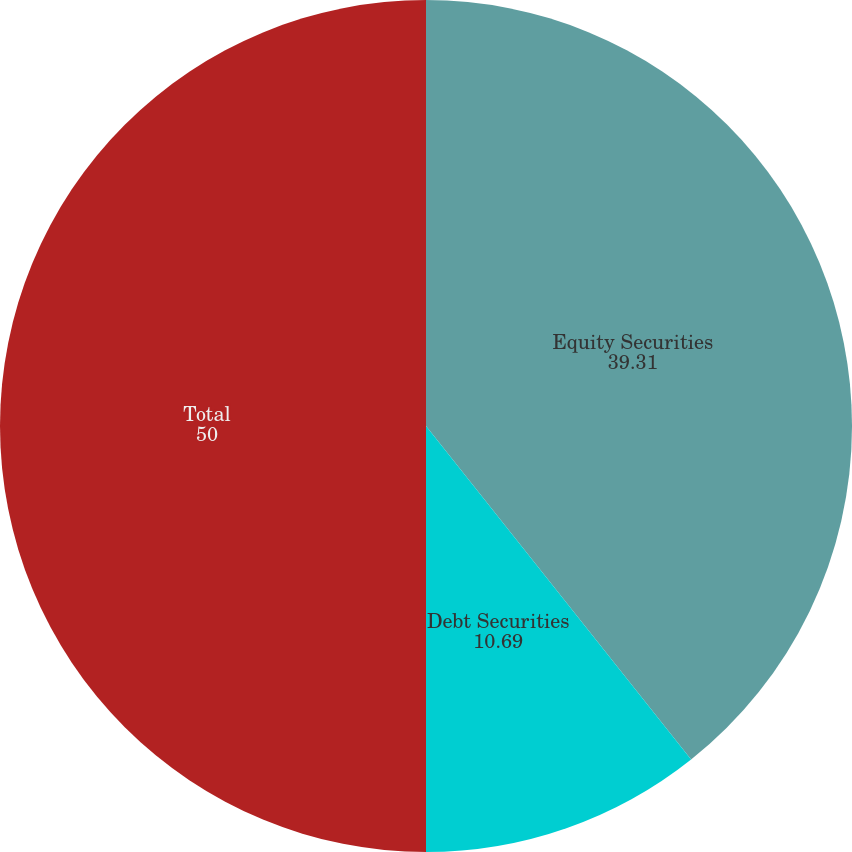Convert chart to OTSL. <chart><loc_0><loc_0><loc_500><loc_500><pie_chart><fcel>Equity Securities<fcel>Debt Securities<fcel>Total<nl><fcel>39.31%<fcel>10.69%<fcel>50.0%<nl></chart> 